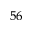Convert formula to latex. <formula><loc_0><loc_0><loc_500><loc_500>^ { 5 6 }</formula> 